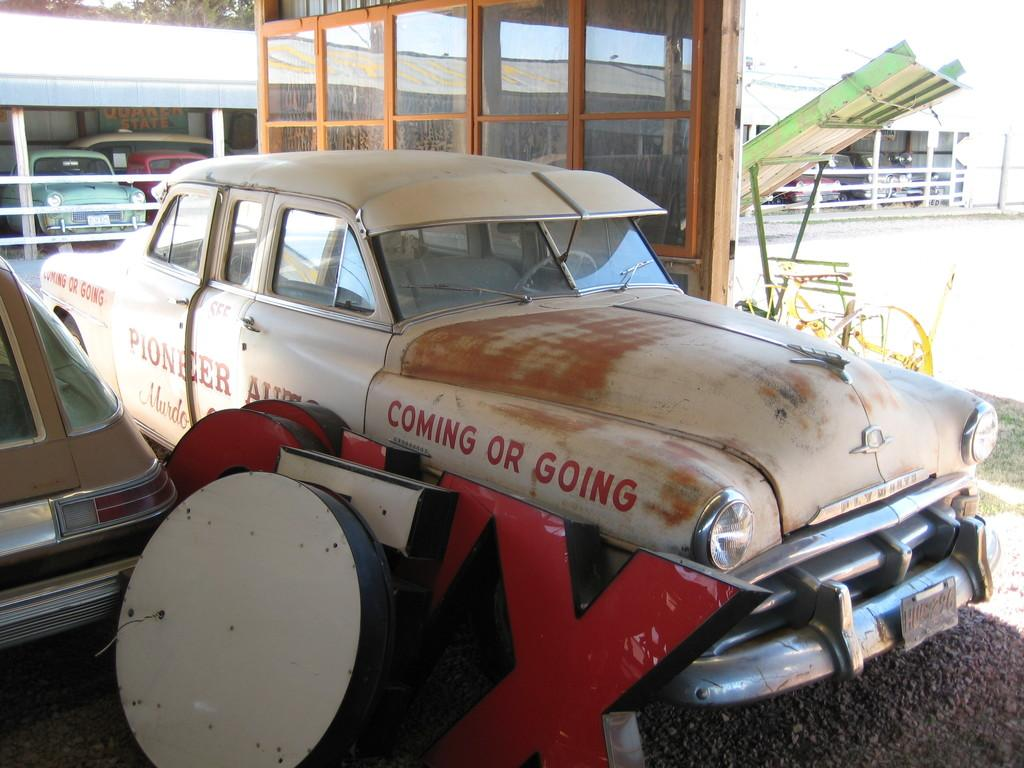<image>
Share a concise interpretation of the image provided. A car says coming or going on the front of it in red letters. 